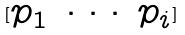<formula> <loc_0><loc_0><loc_500><loc_500>[ \begin{matrix} p _ { 1 } & \cdot \cdot \cdot & p _ { i } \end{matrix} ]</formula> 